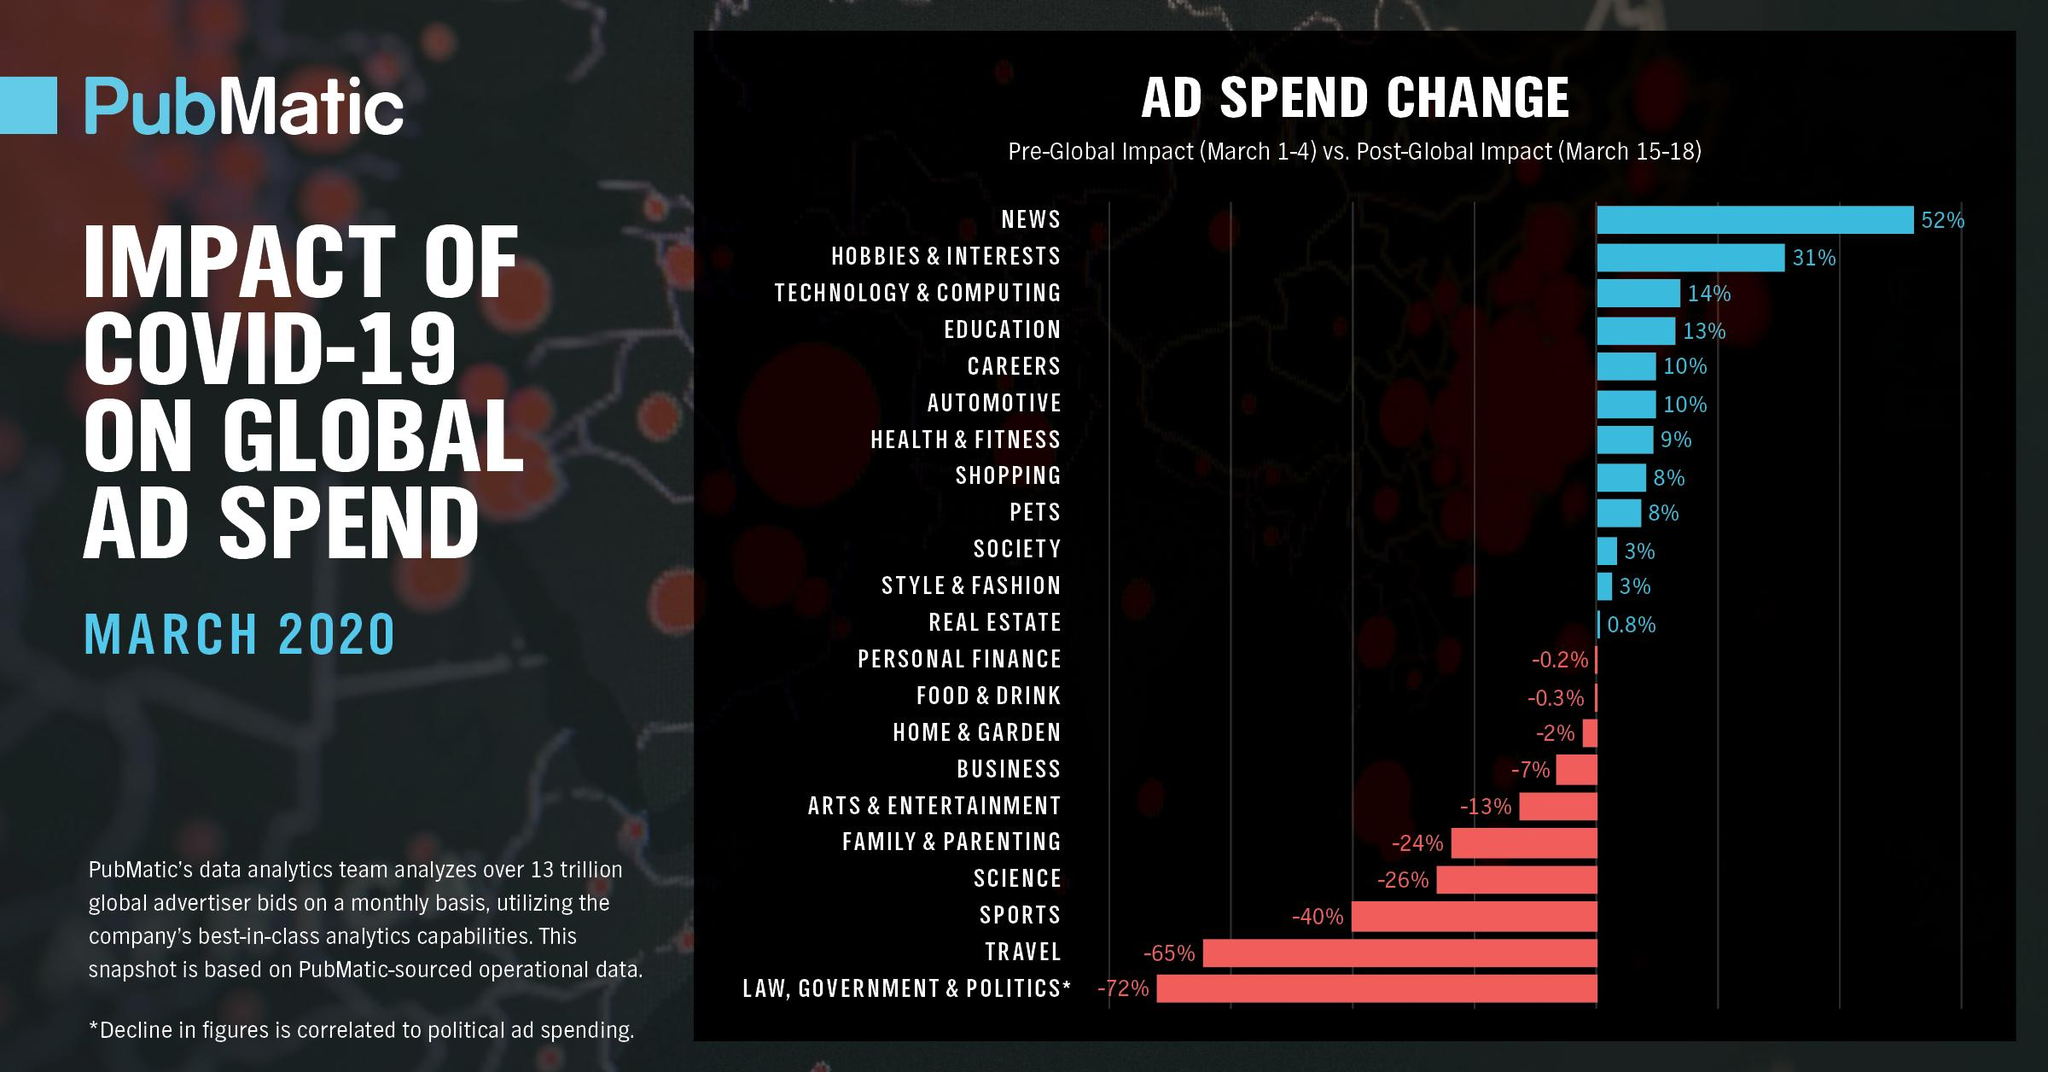Point out several critical features in this image. Approximately 23% of the budget was allocated towards education and careers. 